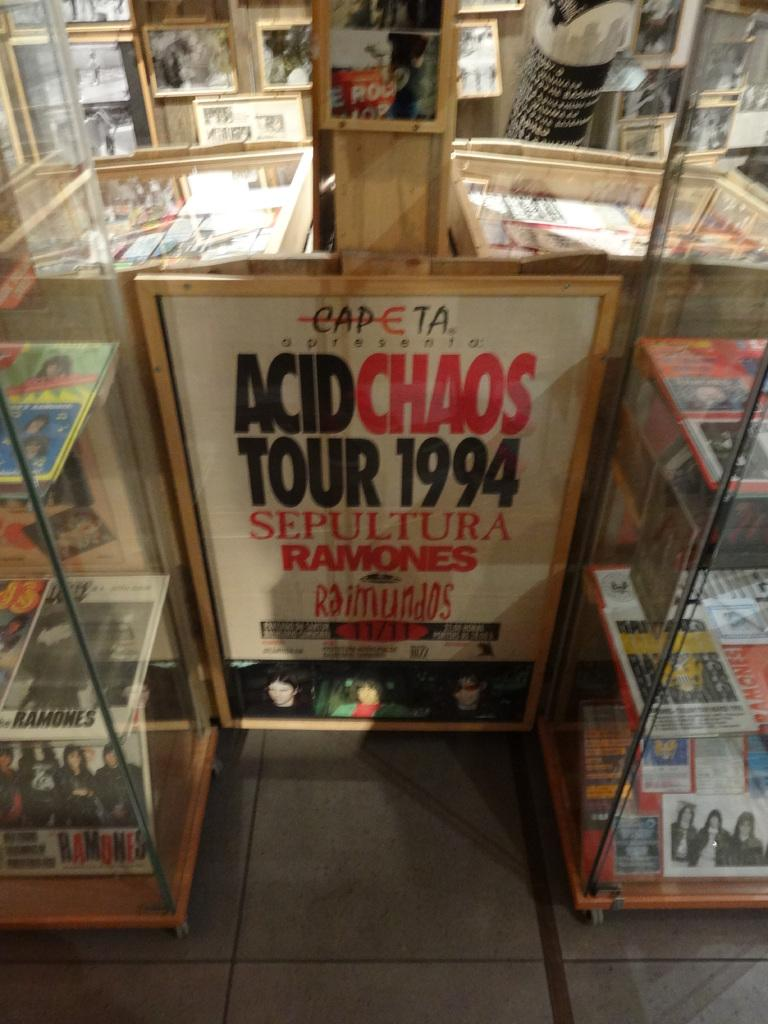Provide a one-sentence caption for the provided image. Acid Chaos Tour poster in white, red and black from 1994. 